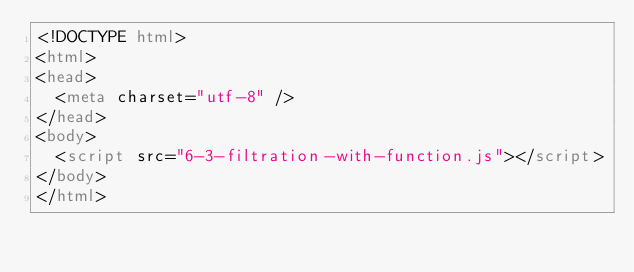<code> <loc_0><loc_0><loc_500><loc_500><_HTML_><!DOCTYPE html>
<html>
<head>
  <meta charset="utf-8" />
</head>
<body>
  <script src="6-3-filtration-with-function.js"></script>
</body>
</html>
</code> 